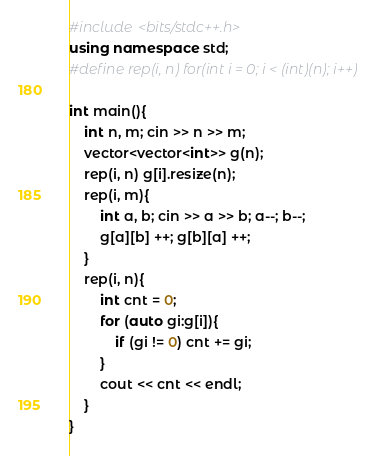Convert code to text. <code><loc_0><loc_0><loc_500><loc_500><_C++_>#include <bits/stdc++.h>
using namespace std;
#define rep(i, n) for(int i = 0; i < (int)(n); i++)

int main(){
    int n, m; cin >> n >> m;
    vector<vector<int>> g(n);
    rep(i, n) g[i].resize(n);
    rep(i, m){
        int a, b; cin >> a >> b; a--; b--;
        g[a][b] ++; g[b][a] ++;
    }
    rep(i, n){
        int cnt = 0;
        for (auto gi:g[i]){
            if (gi != 0) cnt += gi;
        }
        cout << cnt << endl;
    }
}</code> 